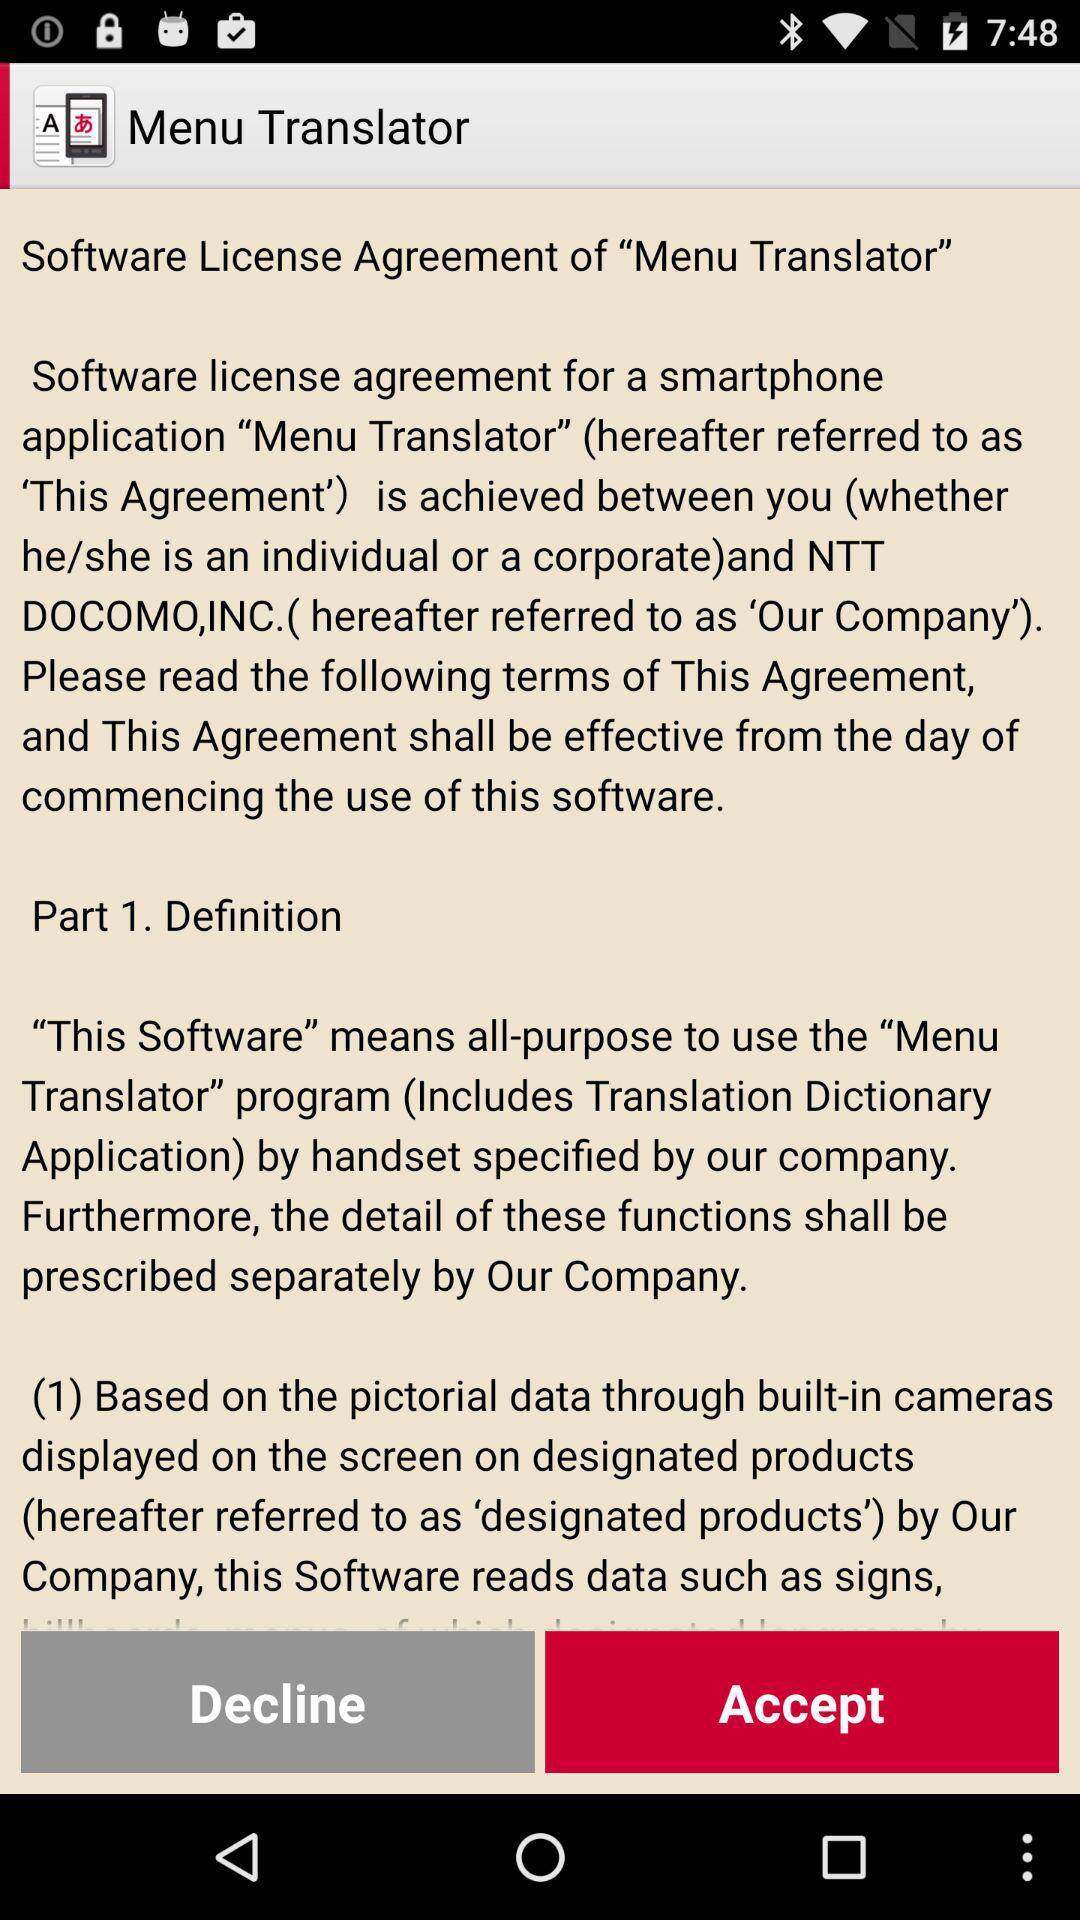What is the application name? The application name is "Menu Translator". 